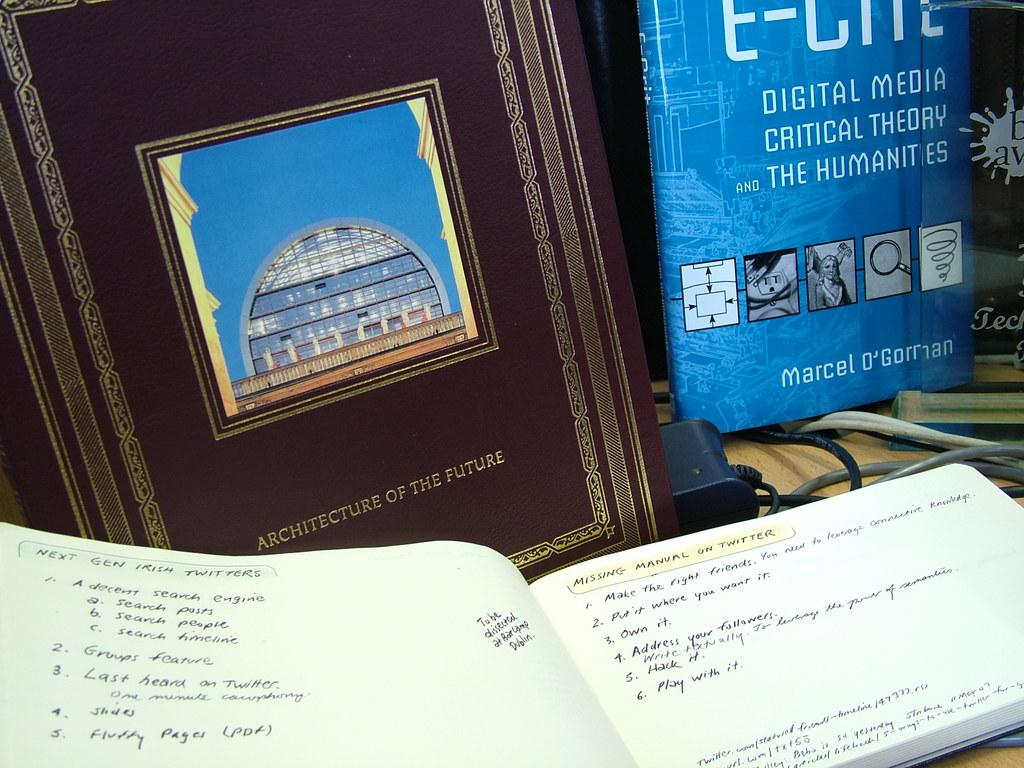<image>
Render a clear and concise summary of the photo. An open book with writing about Twitter in front of a closed copy of Architecture of the Future and E-Cite. 